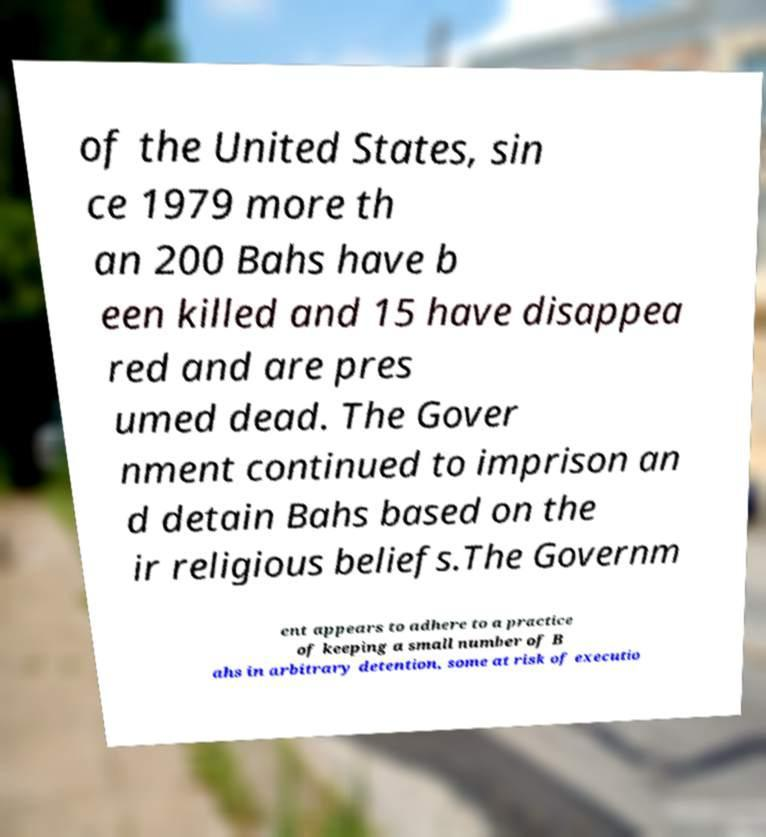Can you accurately transcribe the text from the provided image for me? of the United States, sin ce 1979 more th an 200 Bahs have b een killed and 15 have disappea red and are pres umed dead. The Gover nment continued to imprison an d detain Bahs based on the ir religious beliefs.The Governm ent appears to adhere to a practice of keeping a small number of B ahs in arbitrary detention, some at risk of executio 